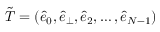<formula> <loc_0><loc_0><loc_500><loc_500>\tilde { T } = ( \hat { e } _ { 0 } , \hat { e } _ { \perp } , \hat { e } _ { 2 } , \dots , \hat { e } _ { N - 1 } )</formula> 